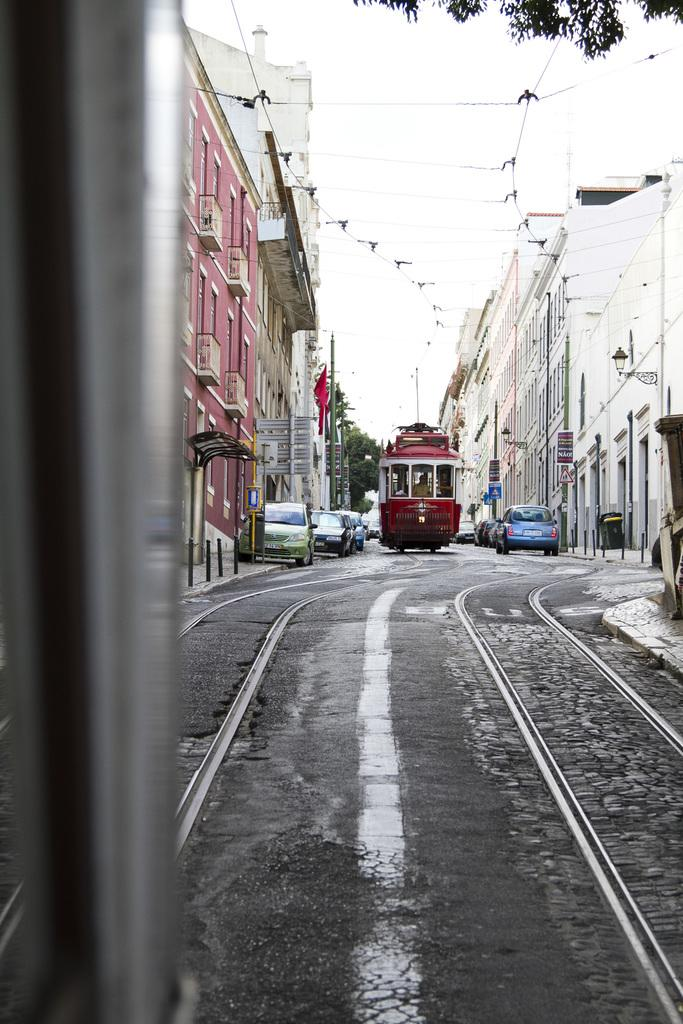What is blocking the road in the image? There is a train in the middle of the road in the image. What other vehicles are present in the image? There are cars on either side of the train. What can be seen in the background of the image? There are buildings on the side of the road. What is visible above the scene? The sky is visible above the scene. Where are the horses resting in the image? There are no horses present in the image. Is there a zoo visible in the background of the image? There is no zoo visible in the image; only buildings are present in the background. 